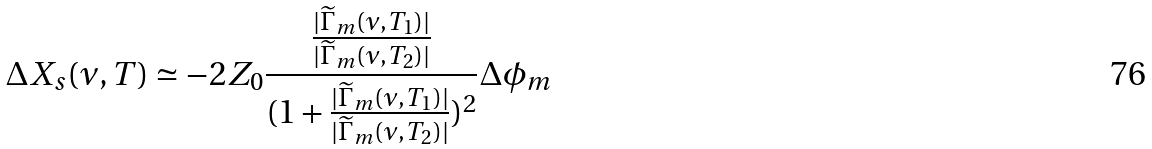<formula> <loc_0><loc_0><loc_500><loc_500>\Delta X _ { s } ( \nu , T ) \simeq - 2 Z _ { 0 } \frac { \frac { | \widetilde { \Gamma } _ { m } ( \nu , T _ { 1 } ) | } { | \widetilde { \Gamma } _ { m } ( \nu , T _ { 2 } ) | } } { ( 1 + \frac { | \widetilde { \Gamma } _ { m } ( \nu , T _ { 1 } ) | } { | \widetilde { \Gamma } _ { m } ( \nu , T _ { 2 } ) | } ) ^ { 2 } } \Delta \phi _ { m }</formula> 